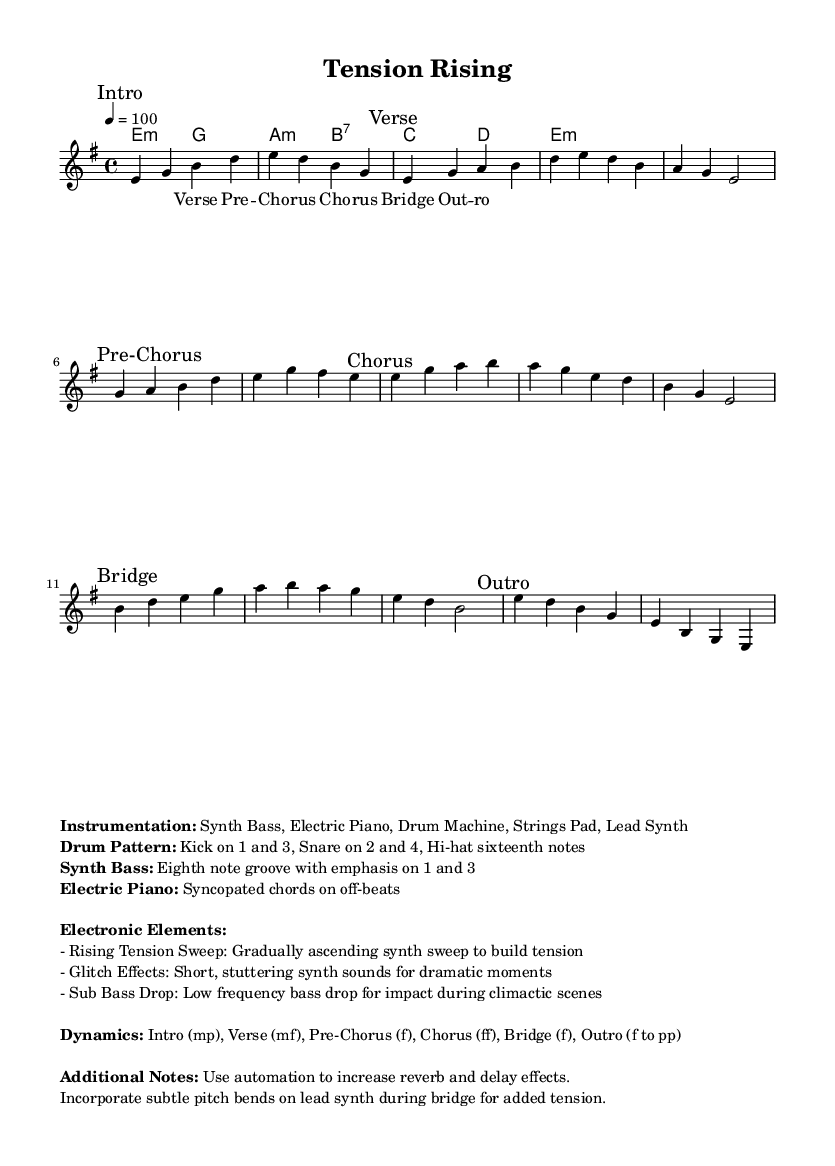What is the key signature of this music? The key signature is E minor, which has one sharp (F#). This can be identified in the beginning of the sheet music where the key is set.
Answer: E minor What is the time signature of this piece? The time signature is 4/4, which means there are four beats per measure. This is indicated at the beginning of the score.
Answer: 4/4 What is the tempo marking for this piece? The tempo marking is 100 BPM, indicated by the number under the tempo sign at the beginning. This specifies that four quarter-note beats should occur each minute.
Answer: 100 How many sections are there in this piece? The sheet music divides into six distinct sections: Intro, Verse, Pre-Chorus, Chorus, Bridge, and Outro. Each section is marked in the melody part clearly.
Answer: Six What instrument is primarily suggested for creating rising tension effects? The electronic elements section specifies using synthesizers for rising tension sweeps, which enhances climactic moments in the music.
Answer: Synthesizer Which chord is used in the chorus? The chorus employs the chords E, A, and B as specified in the harmonies section, which create a consonant and uplifting sound typical in Rhythm and Blues.
Answer: E, A, B 